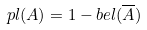<formula> <loc_0><loc_0><loc_500><loc_500>p l ( A ) = 1 - b e l ( \overline { A } )</formula> 